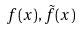<formula> <loc_0><loc_0><loc_500><loc_500>f ( x ) , \tilde { f } ( x )</formula> 